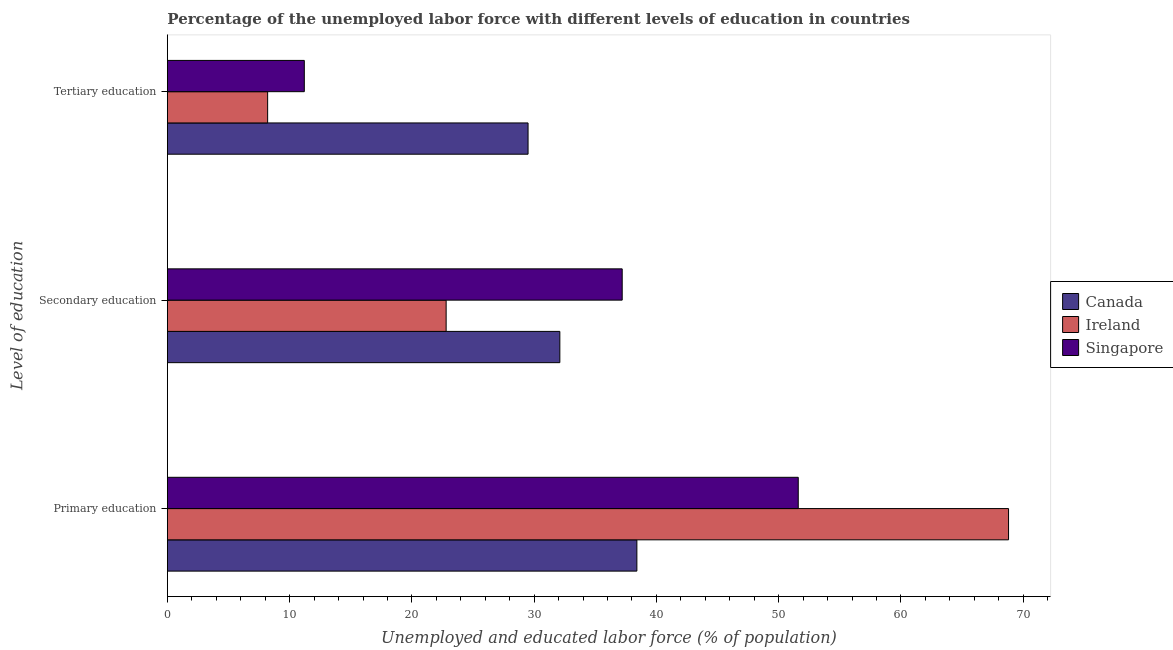How many groups of bars are there?
Your answer should be compact. 3. Are the number of bars per tick equal to the number of legend labels?
Ensure brevity in your answer.  Yes. How many bars are there on the 3rd tick from the top?
Your answer should be compact. 3. How many bars are there on the 1st tick from the bottom?
Make the answer very short. 3. What is the percentage of labor force who received secondary education in Ireland?
Make the answer very short. 22.8. Across all countries, what is the maximum percentage of labor force who received primary education?
Keep it short and to the point. 68.8. Across all countries, what is the minimum percentage of labor force who received tertiary education?
Make the answer very short. 8.2. In which country was the percentage of labor force who received secondary education maximum?
Make the answer very short. Singapore. In which country was the percentage of labor force who received primary education minimum?
Your answer should be compact. Canada. What is the total percentage of labor force who received secondary education in the graph?
Keep it short and to the point. 92.1. What is the difference between the percentage of labor force who received tertiary education in Ireland and that in Singapore?
Offer a very short reply. -3. What is the difference between the percentage of labor force who received tertiary education in Singapore and the percentage of labor force who received primary education in Ireland?
Provide a succinct answer. -57.6. What is the average percentage of labor force who received primary education per country?
Your response must be concise. 52.93. What is the difference between the percentage of labor force who received secondary education and percentage of labor force who received primary education in Singapore?
Your answer should be very brief. -14.4. What is the ratio of the percentage of labor force who received tertiary education in Ireland to that in Singapore?
Make the answer very short. 0.73. Is the difference between the percentage of labor force who received secondary education in Ireland and Singapore greater than the difference between the percentage of labor force who received tertiary education in Ireland and Singapore?
Offer a very short reply. No. What is the difference between the highest and the second highest percentage of labor force who received tertiary education?
Provide a succinct answer. 18.3. What is the difference between the highest and the lowest percentage of labor force who received tertiary education?
Give a very brief answer. 21.3. Is the sum of the percentage of labor force who received tertiary education in Canada and Singapore greater than the maximum percentage of labor force who received secondary education across all countries?
Offer a very short reply. Yes. What does the 3rd bar from the top in Primary education represents?
Provide a short and direct response. Canada. What does the 2nd bar from the bottom in Primary education represents?
Provide a succinct answer. Ireland. How many bars are there?
Your response must be concise. 9. How many countries are there in the graph?
Make the answer very short. 3. Are the values on the major ticks of X-axis written in scientific E-notation?
Ensure brevity in your answer.  No. Where does the legend appear in the graph?
Provide a succinct answer. Center right. How many legend labels are there?
Your answer should be very brief. 3. What is the title of the graph?
Your answer should be very brief. Percentage of the unemployed labor force with different levels of education in countries. What is the label or title of the X-axis?
Give a very brief answer. Unemployed and educated labor force (% of population). What is the label or title of the Y-axis?
Offer a terse response. Level of education. What is the Unemployed and educated labor force (% of population) of Canada in Primary education?
Your response must be concise. 38.4. What is the Unemployed and educated labor force (% of population) in Ireland in Primary education?
Provide a short and direct response. 68.8. What is the Unemployed and educated labor force (% of population) of Singapore in Primary education?
Provide a short and direct response. 51.6. What is the Unemployed and educated labor force (% of population) of Canada in Secondary education?
Offer a terse response. 32.1. What is the Unemployed and educated labor force (% of population) in Ireland in Secondary education?
Your answer should be compact. 22.8. What is the Unemployed and educated labor force (% of population) of Singapore in Secondary education?
Keep it short and to the point. 37.2. What is the Unemployed and educated labor force (% of population) of Canada in Tertiary education?
Keep it short and to the point. 29.5. What is the Unemployed and educated labor force (% of population) in Ireland in Tertiary education?
Ensure brevity in your answer.  8.2. What is the Unemployed and educated labor force (% of population) in Singapore in Tertiary education?
Offer a terse response. 11.2. Across all Level of education, what is the maximum Unemployed and educated labor force (% of population) of Canada?
Your answer should be compact. 38.4. Across all Level of education, what is the maximum Unemployed and educated labor force (% of population) in Ireland?
Your answer should be very brief. 68.8. Across all Level of education, what is the maximum Unemployed and educated labor force (% of population) of Singapore?
Offer a terse response. 51.6. Across all Level of education, what is the minimum Unemployed and educated labor force (% of population) of Canada?
Provide a succinct answer. 29.5. Across all Level of education, what is the minimum Unemployed and educated labor force (% of population) of Ireland?
Offer a very short reply. 8.2. Across all Level of education, what is the minimum Unemployed and educated labor force (% of population) of Singapore?
Make the answer very short. 11.2. What is the total Unemployed and educated labor force (% of population) in Ireland in the graph?
Your response must be concise. 99.8. What is the difference between the Unemployed and educated labor force (% of population) of Canada in Primary education and that in Secondary education?
Offer a very short reply. 6.3. What is the difference between the Unemployed and educated labor force (% of population) in Ireland in Primary education and that in Secondary education?
Offer a terse response. 46. What is the difference between the Unemployed and educated labor force (% of population) in Canada in Primary education and that in Tertiary education?
Your answer should be compact. 8.9. What is the difference between the Unemployed and educated labor force (% of population) of Ireland in Primary education and that in Tertiary education?
Your answer should be compact. 60.6. What is the difference between the Unemployed and educated labor force (% of population) in Singapore in Primary education and that in Tertiary education?
Offer a terse response. 40.4. What is the difference between the Unemployed and educated labor force (% of population) in Ireland in Secondary education and that in Tertiary education?
Offer a terse response. 14.6. What is the difference between the Unemployed and educated labor force (% of population) of Ireland in Primary education and the Unemployed and educated labor force (% of population) of Singapore in Secondary education?
Offer a terse response. 31.6. What is the difference between the Unemployed and educated labor force (% of population) in Canada in Primary education and the Unemployed and educated labor force (% of population) in Ireland in Tertiary education?
Your response must be concise. 30.2. What is the difference between the Unemployed and educated labor force (% of population) in Canada in Primary education and the Unemployed and educated labor force (% of population) in Singapore in Tertiary education?
Offer a very short reply. 27.2. What is the difference between the Unemployed and educated labor force (% of population) of Ireland in Primary education and the Unemployed and educated labor force (% of population) of Singapore in Tertiary education?
Provide a succinct answer. 57.6. What is the difference between the Unemployed and educated labor force (% of population) of Canada in Secondary education and the Unemployed and educated labor force (% of population) of Ireland in Tertiary education?
Provide a short and direct response. 23.9. What is the difference between the Unemployed and educated labor force (% of population) in Canada in Secondary education and the Unemployed and educated labor force (% of population) in Singapore in Tertiary education?
Your response must be concise. 20.9. What is the difference between the Unemployed and educated labor force (% of population) in Ireland in Secondary education and the Unemployed and educated labor force (% of population) in Singapore in Tertiary education?
Your answer should be compact. 11.6. What is the average Unemployed and educated labor force (% of population) in Canada per Level of education?
Ensure brevity in your answer.  33.33. What is the average Unemployed and educated labor force (% of population) in Ireland per Level of education?
Make the answer very short. 33.27. What is the average Unemployed and educated labor force (% of population) in Singapore per Level of education?
Make the answer very short. 33.33. What is the difference between the Unemployed and educated labor force (% of population) in Canada and Unemployed and educated labor force (% of population) in Ireland in Primary education?
Keep it short and to the point. -30.4. What is the difference between the Unemployed and educated labor force (% of population) of Ireland and Unemployed and educated labor force (% of population) of Singapore in Primary education?
Provide a short and direct response. 17.2. What is the difference between the Unemployed and educated labor force (% of population) in Canada and Unemployed and educated labor force (% of population) in Ireland in Secondary education?
Your answer should be very brief. 9.3. What is the difference between the Unemployed and educated labor force (% of population) in Canada and Unemployed and educated labor force (% of population) in Singapore in Secondary education?
Give a very brief answer. -5.1. What is the difference between the Unemployed and educated labor force (% of population) in Ireland and Unemployed and educated labor force (% of population) in Singapore in Secondary education?
Offer a very short reply. -14.4. What is the difference between the Unemployed and educated labor force (% of population) in Canada and Unemployed and educated labor force (% of population) in Ireland in Tertiary education?
Your answer should be compact. 21.3. What is the difference between the Unemployed and educated labor force (% of population) in Canada and Unemployed and educated labor force (% of population) in Singapore in Tertiary education?
Offer a terse response. 18.3. What is the ratio of the Unemployed and educated labor force (% of population) of Canada in Primary education to that in Secondary education?
Provide a short and direct response. 1.2. What is the ratio of the Unemployed and educated labor force (% of population) of Ireland in Primary education to that in Secondary education?
Your response must be concise. 3.02. What is the ratio of the Unemployed and educated labor force (% of population) of Singapore in Primary education to that in Secondary education?
Make the answer very short. 1.39. What is the ratio of the Unemployed and educated labor force (% of population) in Canada in Primary education to that in Tertiary education?
Make the answer very short. 1.3. What is the ratio of the Unemployed and educated labor force (% of population) of Ireland in Primary education to that in Tertiary education?
Offer a terse response. 8.39. What is the ratio of the Unemployed and educated labor force (% of population) in Singapore in Primary education to that in Tertiary education?
Your answer should be very brief. 4.61. What is the ratio of the Unemployed and educated labor force (% of population) of Canada in Secondary education to that in Tertiary education?
Offer a very short reply. 1.09. What is the ratio of the Unemployed and educated labor force (% of population) of Ireland in Secondary education to that in Tertiary education?
Give a very brief answer. 2.78. What is the ratio of the Unemployed and educated labor force (% of population) of Singapore in Secondary education to that in Tertiary education?
Make the answer very short. 3.32. What is the difference between the highest and the second highest Unemployed and educated labor force (% of population) in Canada?
Your answer should be very brief. 6.3. What is the difference between the highest and the second highest Unemployed and educated labor force (% of population) of Ireland?
Your response must be concise. 46. What is the difference between the highest and the second highest Unemployed and educated labor force (% of population) of Singapore?
Offer a very short reply. 14.4. What is the difference between the highest and the lowest Unemployed and educated labor force (% of population) of Ireland?
Give a very brief answer. 60.6. What is the difference between the highest and the lowest Unemployed and educated labor force (% of population) in Singapore?
Offer a terse response. 40.4. 